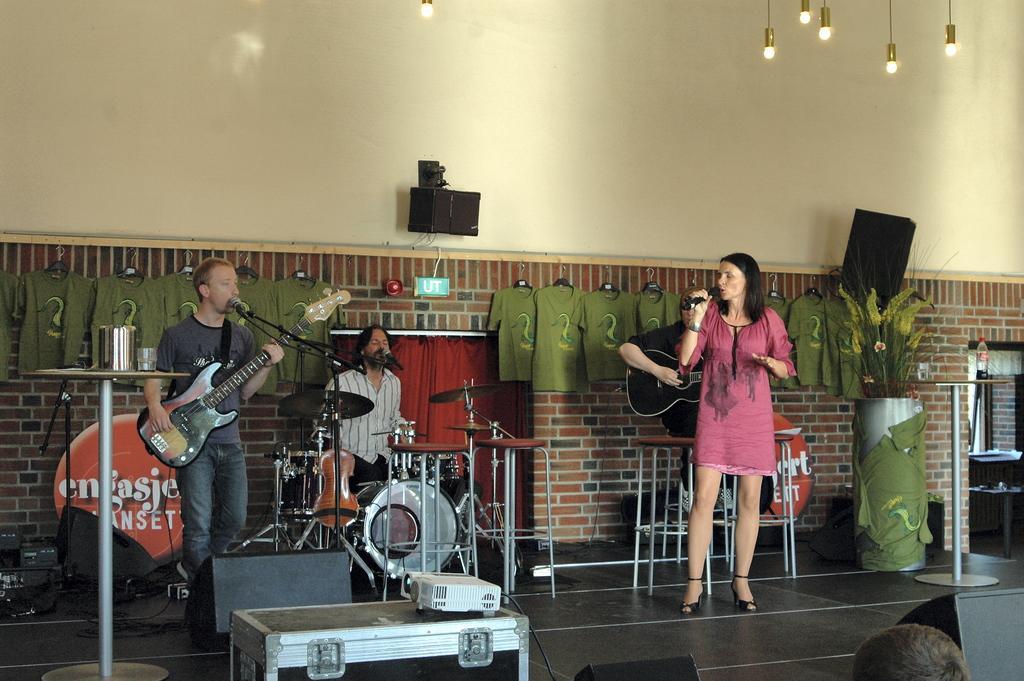How would you summarize this image in a sentence or two? In this image, we can see people and some are holding guitars and one of them is holding a mic and there are some musical instruments and we can see some clothes, which are hanging to the hangers and we can see a bottle, jar and a glass, which are placed on the stands and there is a table and we can see some boxes, which are in black color and there is a wall and we can see some lights. At the bottom, there is a floor and there is a flower plant. 